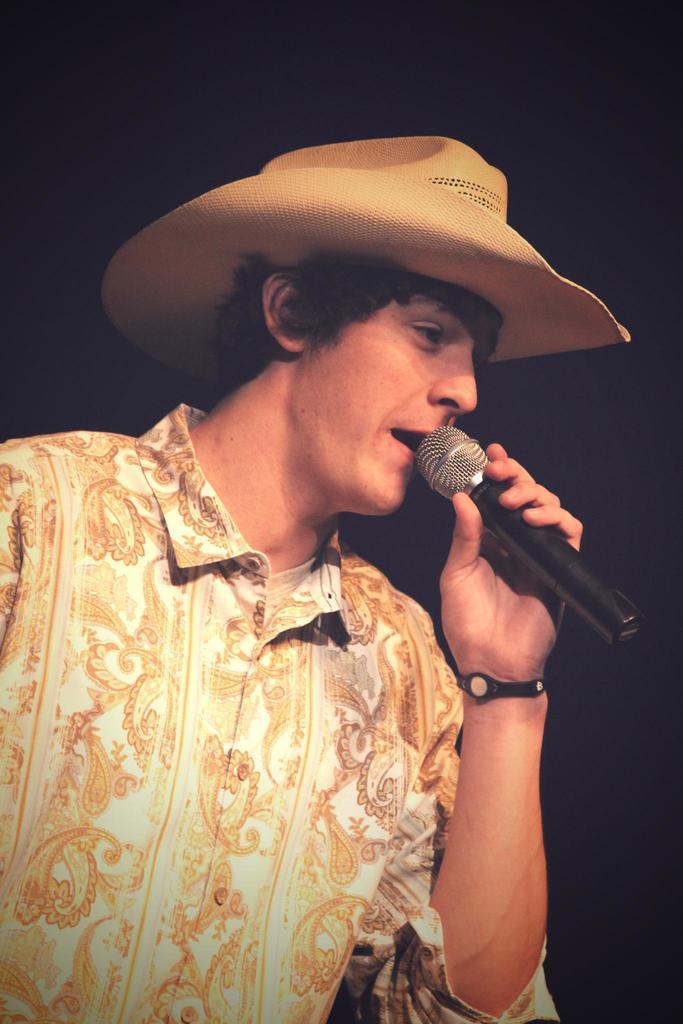In one or two sentences, can you explain what this image depicts? This is the picture of a man, the man is in floral shirt and the man is wearing a hat and a man is holding a microphone. Background of this man is in black color. 